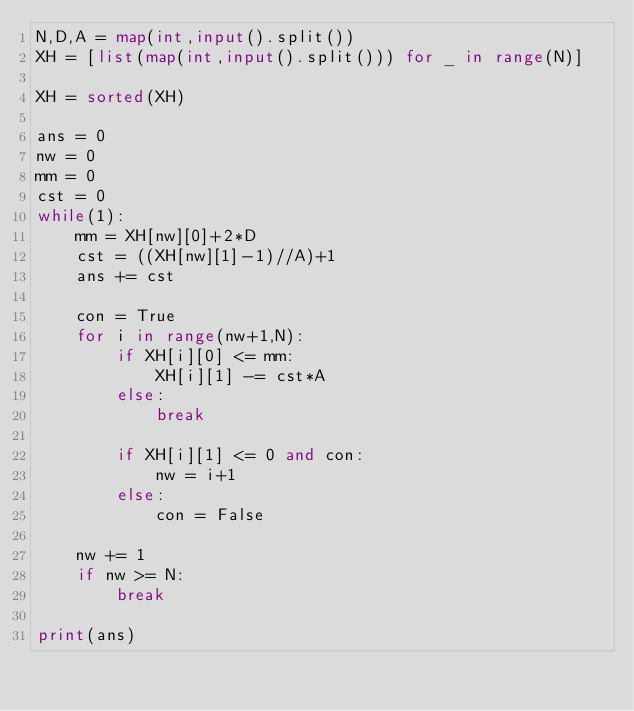<code> <loc_0><loc_0><loc_500><loc_500><_Python_>N,D,A = map(int,input().split())
XH = [list(map(int,input().split())) for _ in range(N)]

XH = sorted(XH)

ans = 0
nw = 0
mm = 0
cst = 0
while(1):
    mm = XH[nw][0]+2*D
    cst = ((XH[nw][1]-1)//A)+1
    ans += cst

    con = True
    for i in range(nw+1,N):
        if XH[i][0] <= mm:
            XH[i][1] -= cst*A
        else:
            break

        if XH[i][1] <= 0 and con:
            nw = i+1
        else:
            con = False

    nw += 1
    if nw >= N:
        break

print(ans)









</code> 